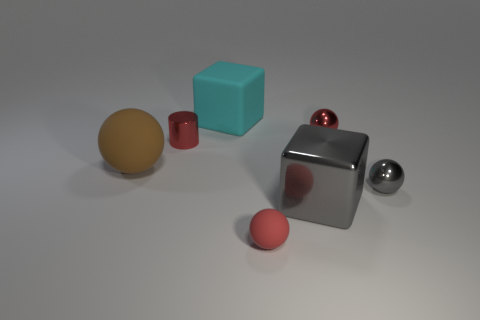Is the number of red metallic cylinders to the left of the cyan rubber block greater than the number of small metallic balls that are in front of the small rubber object?
Your response must be concise. Yes. There is a small metal sphere behind the matte ball that is left of the tiny red matte ball; what is its color?
Offer a terse response. Red. Are there any large rubber things that have the same color as the metallic block?
Provide a short and direct response. No. What is the size of the matte sphere right of the brown sphere that is left of the sphere in front of the large shiny cube?
Your answer should be compact. Small. There is a brown object; what shape is it?
Your answer should be very brief. Sphere. There is a big matte thing that is behind the red shiny cylinder; how many large cyan matte blocks are behind it?
Your response must be concise. 0. How many other objects are the same material as the red cylinder?
Offer a terse response. 3. Does the cube in front of the gray metal ball have the same material as the tiny red sphere in front of the red cylinder?
Your answer should be very brief. No. Does the cylinder have the same material as the small red sphere behind the large brown rubber object?
Provide a succinct answer. Yes. There is a tiny object in front of the tiny shiny ball that is in front of the small red shiny object on the left side of the large gray thing; what is its color?
Provide a succinct answer. Red. 